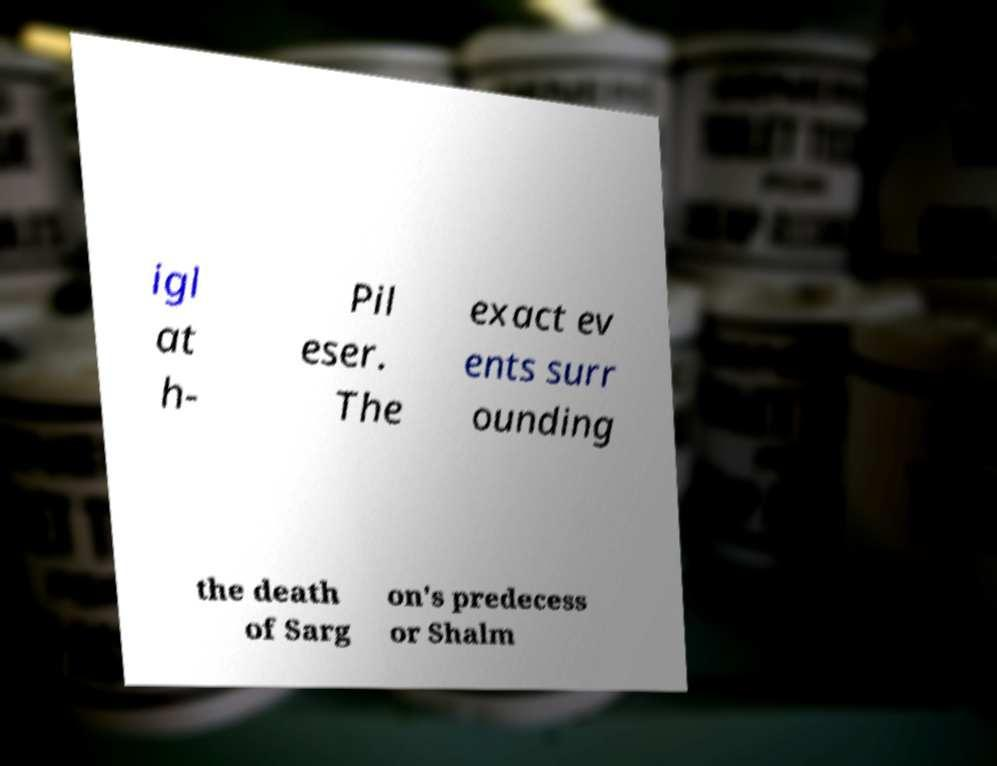Could you extract and type out the text from this image? igl at h- Pil eser. The exact ev ents surr ounding the death of Sarg on's predecess or Shalm 